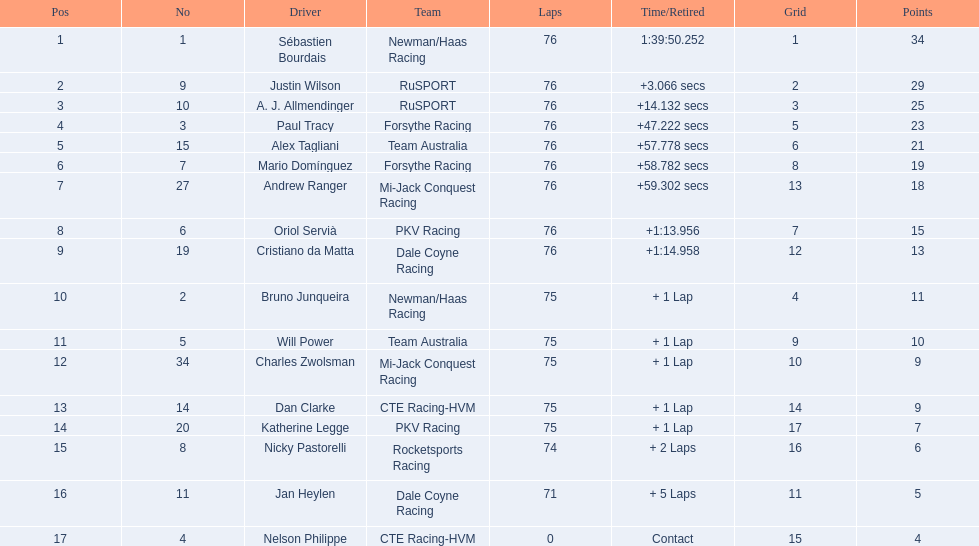How many points did charles zwolsman acquire? 9. Who else got 9 points? Dan Clarke. 